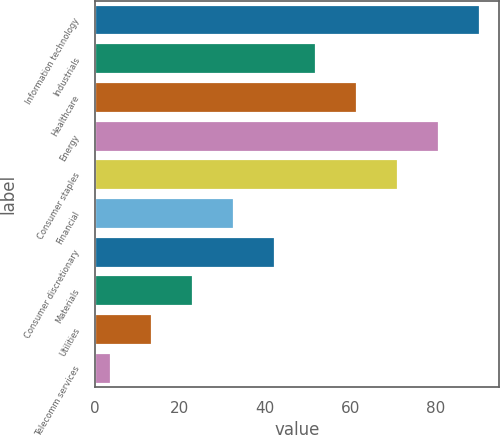Convert chart. <chart><loc_0><loc_0><loc_500><loc_500><bar_chart><fcel>Information technology<fcel>Industrials<fcel>Healthcare<fcel>Energy<fcel>Consumer staples<fcel>Financial<fcel>Consumer discretionary<fcel>Materials<fcel>Utilities<fcel>Telecomm services<nl><fcel>90.39<fcel>51.95<fcel>61.56<fcel>80.78<fcel>71.17<fcel>32.73<fcel>42.34<fcel>23.12<fcel>13.51<fcel>3.9<nl></chart> 